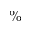<formula> <loc_0><loc_0><loc_500><loc_500>\%</formula> 